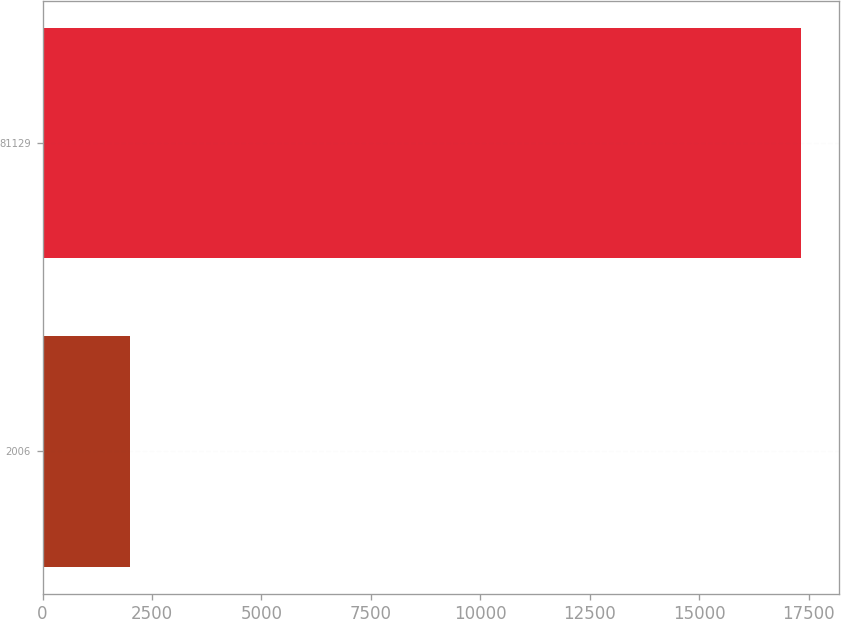<chart> <loc_0><loc_0><loc_500><loc_500><bar_chart><fcel>2006<fcel>81129<nl><fcel>2005<fcel>17324<nl></chart> 